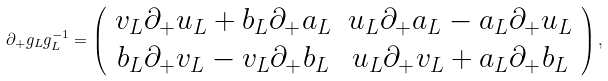<formula> <loc_0><loc_0><loc_500><loc_500>\partial _ { + } g _ { L } g _ { L } ^ { - 1 } = \left ( \begin{array} { c c } { { v _ { L } \partial _ { + } u _ { L } + b _ { L } \partial _ { + } a _ { L } } } & { { u _ { L } \partial _ { + } a _ { L } - a _ { L } \partial _ { + } u _ { L } } } \\ { { b _ { L } \partial _ { + } v _ { L } - v _ { L } \partial _ { + } b _ { L } } } & { { u _ { L } \partial _ { + } v _ { L } + a _ { L } \partial _ { + } b _ { L } } } \end{array} \right ) ,</formula> 